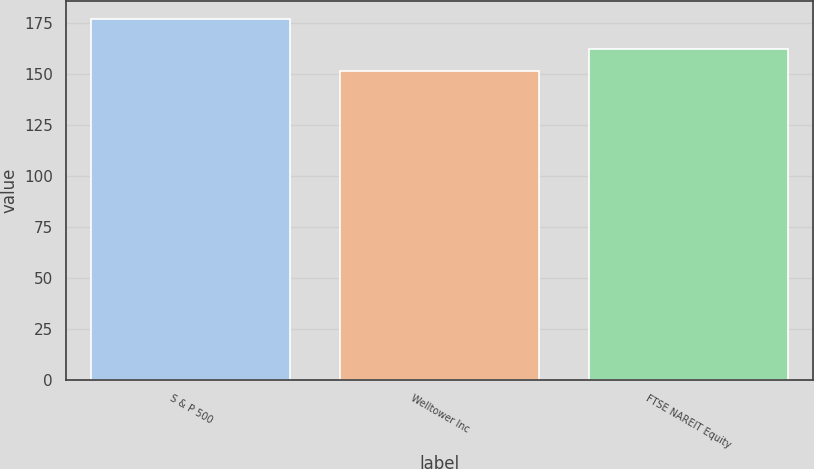<chart> <loc_0><loc_0><loc_500><loc_500><bar_chart><fcel>S & P 500<fcel>Welltower Inc<fcel>FTSE NAREIT Equity<nl><fcel>177.01<fcel>151.58<fcel>162.46<nl></chart> 